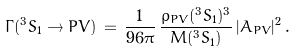Convert formula to latex. <formula><loc_0><loc_0><loc_500><loc_500>\Gamma ( ^ { 3 } S _ { 1 } \to P V ) \, = \, \frac { 1 } { 9 6 \pi } \, \frac { \varrho _ { P V } ( ^ { 3 } S _ { 1 } ) ^ { 3 } } { M ( ^ { 3 } S _ { 1 } ) } \, | A _ { P V } | ^ { 2 } \, .</formula> 